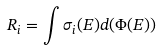<formula> <loc_0><loc_0><loc_500><loc_500>R _ { i } = \int \sigma _ { i } ( E ) d ( \Phi ( E ) )</formula> 